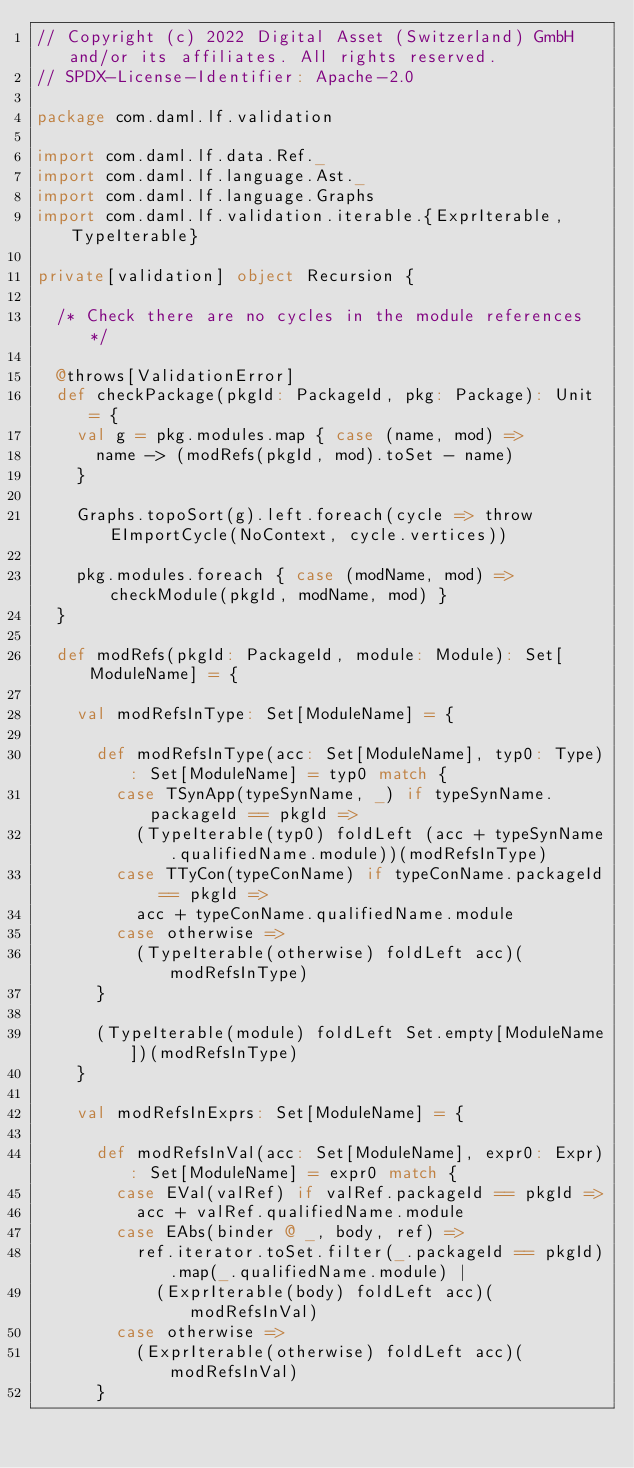Convert code to text. <code><loc_0><loc_0><loc_500><loc_500><_Scala_>// Copyright (c) 2022 Digital Asset (Switzerland) GmbH and/or its affiliates. All rights reserved.
// SPDX-License-Identifier: Apache-2.0

package com.daml.lf.validation

import com.daml.lf.data.Ref._
import com.daml.lf.language.Ast._
import com.daml.lf.language.Graphs
import com.daml.lf.validation.iterable.{ExprIterable, TypeIterable}

private[validation] object Recursion {

  /* Check there are no cycles in the module references */

  @throws[ValidationError]
  def checkPackage(pkgId: PackageId, pkg: Package): Unit = {
    val g = pkg.modules.map { case (name, mod) =>
      name -> (modRefs(pkgId, mod).toSet - name)
    }

    Graphs.topoSort(g).left.foreach(cycle => throw EImportCycle(NoContext, cycle.vertices))

    pkg.modules.foreach { case (modName, mod) => checkModule(pkgId, modName, mod) }
  }

  def modRefs(pkgId: PackageId, module: Module): Set[ModuleName] = {

    val modRefsInType: Set[ModuleName] = {

      def modRefsInType(acc: Set[ModuleName], typ0: Type): Set[ModuleName] = typ0 match {
        case TSynApp(typeSynName, _) if typeSynName.packageId == pkgId =>
          (TypeIterable(typ0) foldLeft (acc + typeSynName.qualifiedName.module))(modRefsInType)
        case TTyCon(typeConName) if typeConName.packageId == pkgId =>
          acc + typeConName.qualifiedName.module
        case otherwise =>
          (TypeIterable(otherwise) foldLeft acc)(modRefsInType)
      }

      (TypeIterable(module) foldLeft Set.empty[ModuleName])(modRefsInType)
    }

    val modRefsInExprs: Set[ModuleName] = {

      def modRefsInVal(acc: Set[ModuleName], expr0: Expr): Set[ModuleName] = expr0 match {
        case EVal(valRef) if valRef.packageId == pkgId =>
          acc + valRef.qualifiedName.module
        case EAbs(binder @ _, body, ref) =>
          ref.iterator.toSet.filter(_.packageId == pkgId).map(_.qualifiedName.module) |
            (ExprIterable(body) foldLeft acc)(modRefsInVal)
        case otherwise =>
          (ExprIterable(otherwise) foldLeft acc)(modRefsInVal)
      }
</code> 